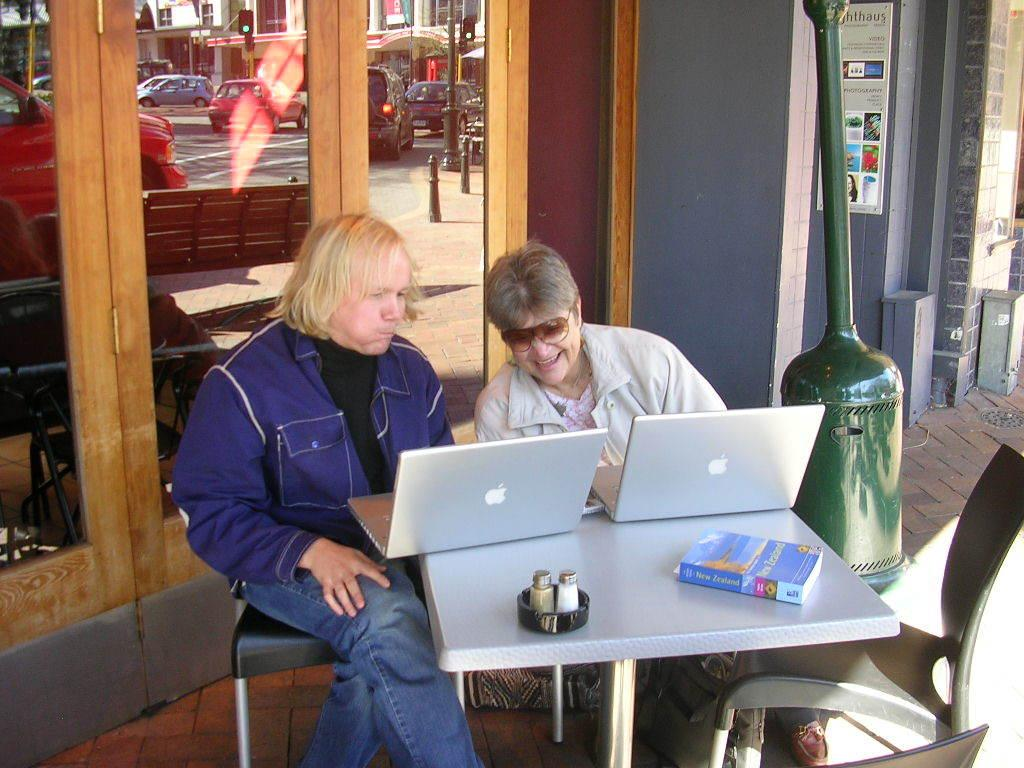What are the two people in the image doing? The two people are sitting. What objects can be seen on the table in the image? There are two laptops and a book on the table. What is visible behind the people in the image? There are doors visible behind the people. What type of sound can be heard coming from the nation in the image? There is no nation present in the image, and therefore no sound can be heard from it. 